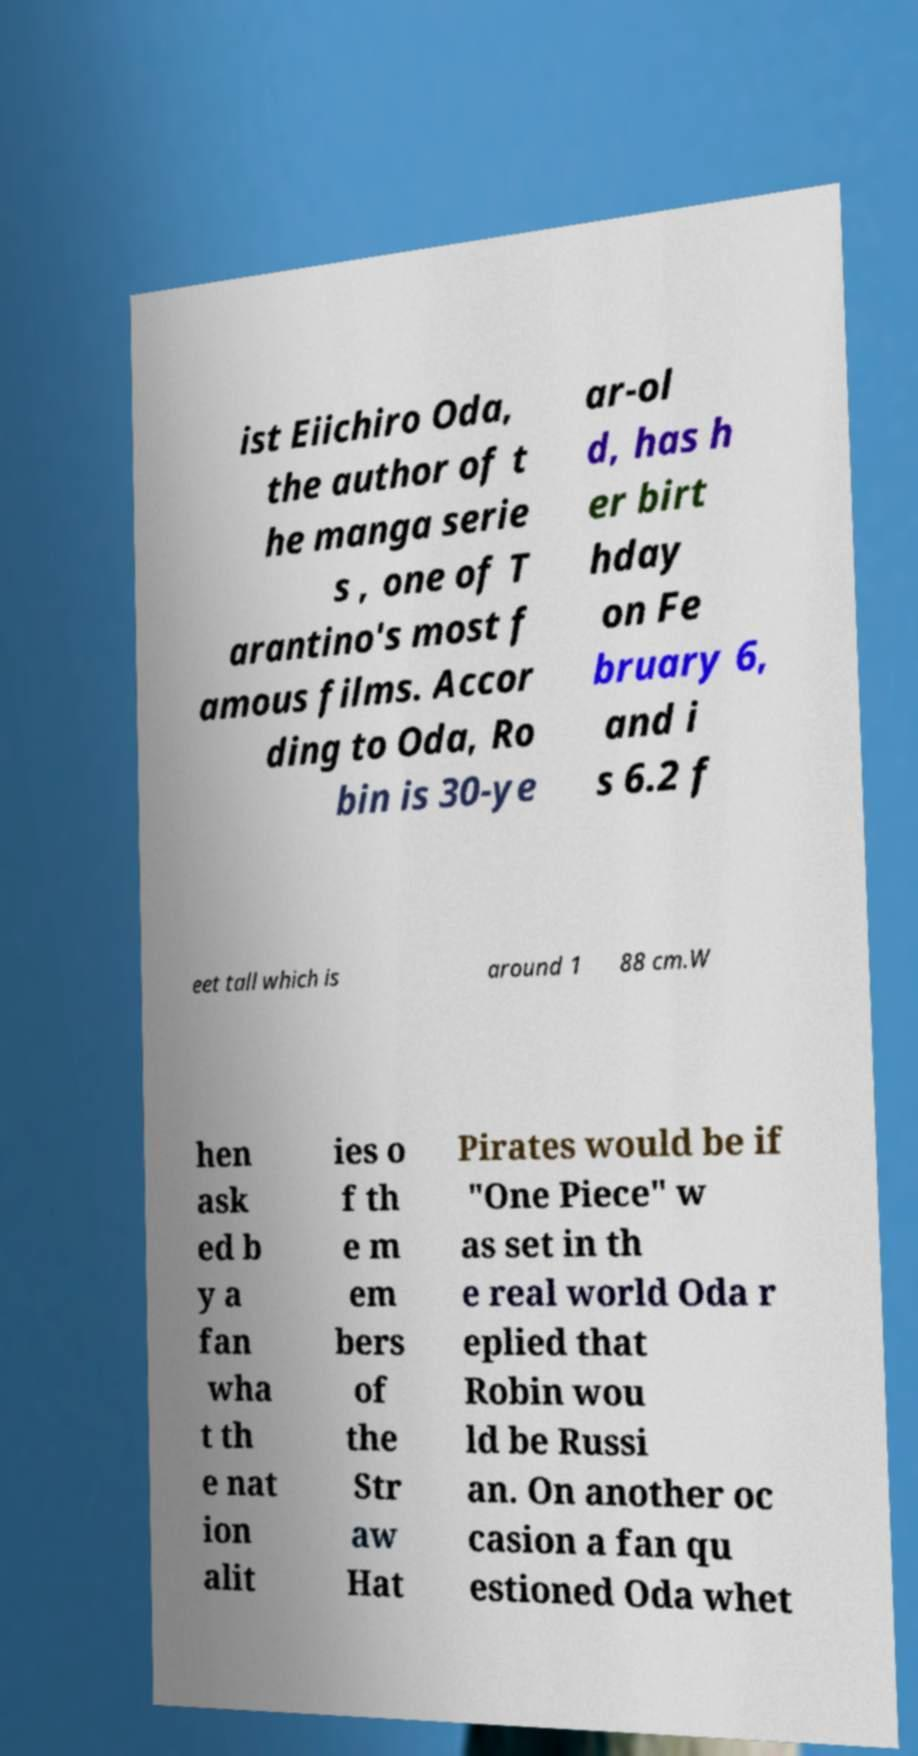There's text embedded in this image that I need extracted. Can you transcribe it verbatim? ist Eiichiro Oda, the author of t he manga serie s , one of T arantino's most f amous films. Accor ding to Oda, Ro bin is 30-ye ar-ol d, has h er birt hday on Fe bruary 6, and i s 6.2 f eet tall which is around 1 88 cm.W hen ask ed b y a fan wha t th e nat ion alit ies o f th e m em bers of the Str aw Hat Pirates would be if "One Piece" w as set in th e real world Oda r eplied that Robin wou ld be Russi an. On another oc casion a fan qu estioned Oda whet 